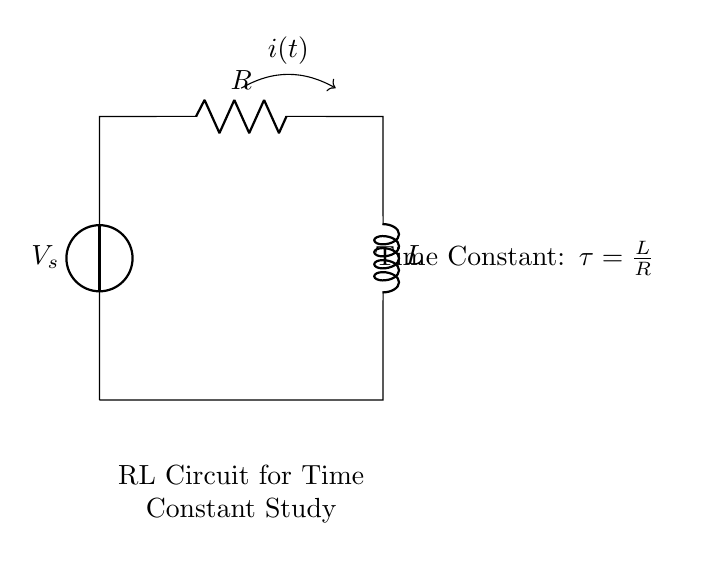What does the circuit contain? The circuit contains a voltage source, a resistor, and an inductor, forming an RL circuit. Each component is essential for studying the behavior of the circuit, especially the time constant.
Answer: voltage source, resistor, inductor What is the time constant in this circuit? The time constant, denoted by the symbol tau, is calculated using the formula tau equals L divided by R. This relationship indicates how quickly the current builds in the inductor relative to the resistance.
Answer: tau = L/R What is the significance of the arrow representing current? The arrow indicates the direction of current flow in the circuit, which is essential for understanding how the components interact and the resulting voltage across each component over time.
Answer: direction of current flow How is the inductor connected in the circuit? The inductor is connected in series with the resistor and voltage source, which means the same current flows through both components. This configuration is typical for RL circuits.
Answer: in series What happens to current when the switch closes in an RL circuit? When the switch closes, the current does not instantly reach its maximum value; instead, it gradually increases over time, governed by the time constant of the circuit. This is a key characteristic of RL circuits.
Answer: gradually increases What does a higher value of L or a lower value of R indicate about tau? A higher value of L or a lower value of R results in a larger time constant tau, meaning the circuit takes longer to reach the steady-state current. This relationship is crucial for understanding the responsiveness of RL circuits.
Answer: larger tau 